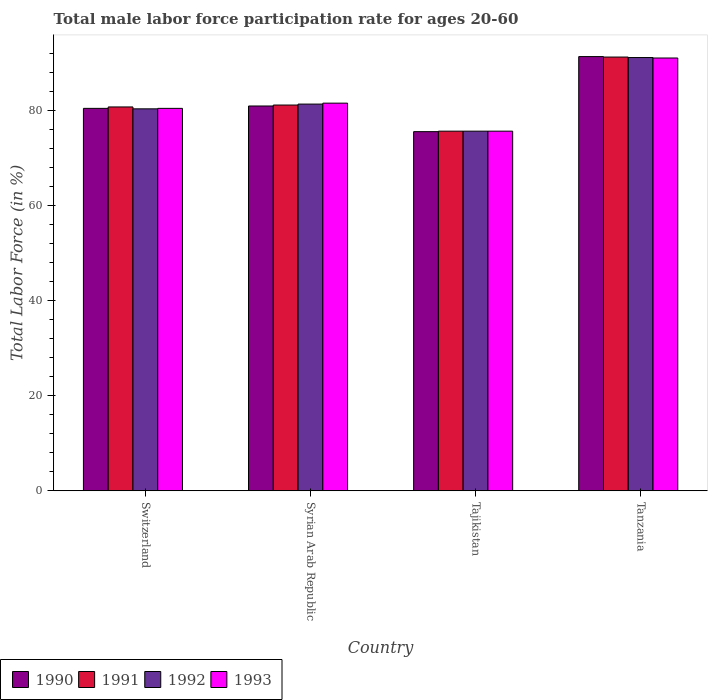Are the number of bars per tick equal to the number of legend labels?
Make the answer very short. Yes. Are the number of bars on each tick of the X-axis equal?
Provide a short and direct response. Yes. What is the label of the 1st group of bars from the left?
Your response must be concise. Switzerland. What is the male labor force participation rate in 1992 in Switzerland?
Provide a short and direct response. 80.4. Across all countries, what is the maximum male labor force participation rate in 1991?
Provide a short and direct response. 91.3. Across all countries, what is the minimum male labor force participation rate in 1993?
Ensure brevity in your answer.  75.7. In which country was the male labor force participation rate in 1993 maximum?
Your answer should be compact. Tanzania. In which country was the male labor force participation rate in 1992 minimum?
Give a very brief answer. Tajikistan. What is the total male labor force participation rate in 1992 in the graph?
Provide a short and direct response. 328.7. What is the difference between the male labor force participation rate in 1993 in Switzerland and that in Syrian Arab Republic?
Your answer should be compact. -1.1. What is the difference between the male labor force participation rate in 1990 in Tanzania and the male labor force participation rate in 1993 in Syrian Arab Republic?
Provide a short and direct response. 9.8. What is the average male labor force participation rate in 1993 per country?
Give a very brief answer. 82.22. What is the difference between the male labor force participation rate of/in 1993 and male labor force participation rate of/in 1991 in Syrian Arab Republic?
Give a very brief answer. 0.4. What is the ratio of the male labor force participation rate in 1991 in Switzerland to that in Tajikistan?
Provide a succinct answer. 1.07. Is the male labor force participation rate in 1990 in Syrian Arab Republic less than that in Tajikistan?
Offer a very short reply. No. Is the difference between the male labor force participation rate in 1993 in Syrian Arab Republic and Tanzania greater than the difference between the male labor force participation rate in 1991 in Syrian Arab Republic and Tanzania?
Make the answer very short. Yes. What is the difference between the highest and the lowest male labor force participation rate in 1990?
Offer a terse response. 15.8. Is the sum of the male labor force participation rate in 1990 in Switzerland and Tanzania greater than the maximum male labor force participation rate in 1992 across all countries?
Your answer should be very brief. Yes. Is it the case that in every country, the sum of the male labor force participation rate in 1990 and male labor force participation rate in 1993 is greater than the sum of male labor force participation rate in 1991 and male labor force participation rate in 1992?
Provide a succinct answer. No. What does the 2nd bar from the right in Syrian Arab Republic represents?
Make the answer very short. 1992. Are all the bars in the graph horizontal?
Provide a short and direct response. No. Does the graph contain any zero values?
Offer a very short reply. No. Where does the legend appear in the graph?
Give a very brief answer. Bottom left. How are the legend labels stacked?
Provide a short and direct response. Horizontal. What is the title of the graph?
Offer a terse response. Total male labor force participation rate for ages 20-60. What is the label or title of the Y-axis?
Keep it short and to the point. Total Labor Force (in %). What is the Total Labor Force (in %) in 1990 in Switzerland?
Make the answer very short. 80.5. What is the Total Labor Force (in %) of 1991 in Switzerland?
Offer a terse response. 80.8. What is the Total Labor Force (in %) of 1992 in Switzerland?
Provide a short and direct response. 80.4. What is the Total Labor Force (in %) in 1993 in Switzerland?
Your answer should be very brief. 80.5. What is the Total Labor Force (in %) of 1990 in Syrian Arab Republic?
Ensure brevity in your answer.  81. What is the Total Labor Force (in %) of 1991 in Syrian Arab Republic?
Provide a succinct answer. 81.2. What is the Total Labor Force (in %) in 1992 in Syrian Arab Republic?
Provide a succinct answer. 81.4. What is the Total Labor Force (in %) of 1993 in Syrian Arab Republic?
Give a very brief answer. 81.6. What is the Total Labor Force (in %) of 1990 in Tajikistan?
Provide a succinct answer. 75.6. What is the Total Labor Force (in %) of 1991 in Tajikistan?
Your answer should be compact. 75.7. What is the Total Labor Force (in %) of 1992 in Tajikistan?
Ensure brevity in your answer.  75.7. What is the Total Labor Force (in %) of 1993 in Tajikistan?
Ensure brevity in your answer.  75.7. What is the Total Labor Force (in %) in 1990 in Tanzania?
Give a very brief answer. 91.4. What is the Total Labor Force (in %) of 1991 in Tanzania?
Offer a terse response. 91.3. What is the Total Labor Force (in %) in 1992 in Tanzania?
Your answer should be very brief. 91.2. What is the Total Labor Force (in %) in 1993 in Tanzania?
Your answer should be very brief. 91.1. Across all countries, what is the maximum Total Labor Force (in %) in 1990?
Your response must be concise. 91.4. Across all countries, what is the maximum Total Labor Force (in %) of 1991?
Offer a terse response. 91.3. Across all countries, what is the maximum Total Labor Force (in %) in 1992?
Your response must be concise. 91.2. Across all countries, what is the maximum Total Labor Force (in %) in 1993?
Offer a very short reply. 91.1. Across all countries, what is the minimum Total Labor Force (in %) of 1990?
Your answer should be very brief. 75.6. Across all countries, what is the minimum Total Labor Force (in %) in 1991?
Provide a short and direct response. 75.7. Across all countries, what is the minimum Total Labor Force (in %) of 1992?
Your answer should be very brief. 75.7. Across all countries, what is the minimum Total Labor Force (in %) in 1993?
Your answer should be very brief. 75.7. What is the total Total Labor Force (in %) of 1990 in the graph?
Offer a very short reply. 328.5. What is the total Total Labor Force (in %) in 1991 in the graph?
Your answer should be compact. 329. What is the total Total Labor Force (in %) of 1992 in the graph?
Your answer should be compact. 328.7. What is the total Total Labor Force (in %) in 1993 in the graph?
Provide a succinct answer. 328.9. What is the difference between the Total Labor Force (in %) in 1990 in Switzerland and that in Syrian Arab Republic?
Make the answer very short. -0.5. What is the difference between the Total Labor Force (in %) of 1990 in Switzerland and that in Tajikistan?
Provide a short and direct response. 4.9. What is the difference between the Total Labor Force (in %) of 1991 in Switzerland and that in Tajikistan?
Your answer should be very brief. 5.1. What is the difference between the Total Labor Force (in %) of 1992 in Switzerland and that in Tajikistan?
Your answer should be very brief. 4.7. What is the difference between the Total Labor Force (in %) of 1993 in Switzerland and that in Tajikistan?
Offer a very short reply. 4.8. What is the difference between the Total Labor Force (in %) in 1990 in Switzerland and that in Tanzania?
Offer a terse response. -10.9. What is the difference between the Total Labor Force (in %) of 1992 in Switzerland and that in Tanzania?
Give a very brief answer. -10.8. What is the difference between the Total Labor Force (in %) of 1990 in Syrian Arab Republic and that in Tajikistan?
Keep it short and to the point. 5.4. What is the difference between the Total Labor Force (in %) in 1993 in Syrian Arab Republic and that in Tajikistan?
Provide a short and direct response. 5.9. What is the difference between the Total Labor Force (in %) of 1992 in Syrian Arab Republic and that in Tanzania?
Make the answer very short. -9.8. What is the difference between the Total Labor Force (in %) in 1993 in Syrian Arab Republic and that in Tanzania?
Your answer should be very brief. -9.5. What is the difference between the Total Labor Force (in %) of 1990 in Tajikistan and that in Tanzania?
Provide a succinct answer. -15.8. What is the difference between the Total Labor Force (in %) in 1991 in Tajikistan and that in Tanzania?
Provide a short and direct response. -15.6. What is the difference between the Total Labor Force (in %) of 1992 in Tajikistan and that in Tanzania?
Give a very brief answer. -15.5. What is the difference between the Total Labor Force (in %) of 1993 in Tajikistan and that in Tanzania?
Make the answer very short. -15.4. What is the difference between the Total Labor Force (in %) in 1990 in Switzerland and the Total Labor Force (in %) in 1991 in Syrian Arab Republic?
Your answer should be compact. -0.7. What is the difference between the Total Labor Force (in %) in 1990 in Switzerland and the Total Labor Force (in %) in 1992 in Syrian Arab Republic?
Provide a short and direct response. -0.9. What is the difference between the Total Labor Force (in %) in 1990 in Switzerland and the Total Labor Force (in %) in 1993 in Syrian Arab Republic?
Ensure brevity in your answer.  -1.1. What is the difference between the Total Labor Force (in %) in 1991 in Switzerland and the Total Labor Force (in %) in 1992 in Syrian Arab Republic?
Make the answer very short. -0.6. What is the difference between the Total Labor Force (in %) in 1992 in Switzerland and the Total Labor Force (in %) in 1993 in Syrian Arab Republic?
Your answer should be compact. -1.2. What is the difference between the Total Labor Force (in %) in 1990 in Switzerland and the Total Labor Force (in %) in 1991 in Tajikistan?
Ensure brevity in your answer.  4.8. What is the difference between the Total Labor Force (in %) in 1991 in Switzerland and the Total Labor Force (in %) in 1992 in Tajikistan?
Provide a succinct answer. 5.1. What is the difference between the Total Labor Force (in %) of 1992 in Switzerland and the Total Labor Force (in %) of 1993 in Tajikistan?
Your response must be concise. 4.7. What is the difference between the Total Labor Force (in %) of 1990 in Switzerland and the Total Labor Force (in %) of 1991 in Tanzania?
Your response must be concise. -10.8. What is the difference between the Total Labor Force (in %) of 1990 in Switzerland and the Total Labor Force (in %) of 1992 in Tanzania?
Offer a very short reply. -10.7. What is the difference between the Total Labor Force (in %) of 1991 in Switzerland and the Total Labor Force (in %) of 1992 in Tanzania?
Offer a terse response. -10.4. What is the difference between the Total Labor Force (in %) in 1990 in Syrian Arab Republic and the Total Labor Force (in %) in 1991 in Tajikistan?
Your response must be concise. 5.3. What is the difference between the Total Labor Force (in %) of 1990 in Syrian Arab Republic and the Total Labor Force (in %) of 1993 in Tajikistan?
Your response must be concise. 5.3. What is the difference between the Total Labor Force (in %) of 1991 in Syrian Arab Republic and the Total Labor Force (in %) of 1993 in Tajikistan?
Your answer should be very brief. 5.5. What is the difference between the Total Labor Force (in %) of 1992 in Syrian Arab Republic and the Total Labor Force (in %) of 1993 in Tajikistan?
Make the answer very short. 5.7. What is the difference between the Total Labor Force (in %) in 1990 in Syrian Arab Republic and the Total Labor Force (in %) in 1992 in Tanzania?
Your answer should be very brief. -10.2. What is the difference between the Total Labor Force (in %) of 1990 in Syrian Arab Republic and the Total Labor Force (in %) of 1993 in Tanzania?
Offer a very short reply. -10.1. What is the difference between the Total Labor Force (in %) in 1991 in Syrian Arab Republic and the Total Labor Force (in %) in 1993 in Tanzania?
Give a very brief answer. -9.9. What is the difference between the Total Labor Force (in %) of 1992 in Syrian Arab Republic and the Total Labor Force (in %) of 1993 in Tanzania?
Offer a very short reply. -9.7. What is the difference between the Total Labor Force (in %) in 1990 in Tajikistan and the Total Labor Force (in %) in 1991 in Tanzania?
Your response must be concise. -15.7. What is the difference between the Total Labor Force (in %) of 1990 in Tajikistan and the Total Labor Force (in %) of 1992 in Tanzania?
Make the answer very short. -15.6. What is the difference between the Total Labor Force (in %) in 1990 in Tajikistan and the Total Labor Force (in %) in 1993 in Tanzania?
Offer a terse response. -15.5. What is the difference between the Total Labor Force (in %) of 1991 in Tajikistan and the Total Labor Force (in %) of 1992 in Tanzania?
Provide a short and direct response. -15.5. What is the difference between the Total Labor Force (in %) in 1991 in Tajikistan and the Total Labor Force (in %) in 1993 in Tanzania?
Your response must be concise. -15.4. What is the difference between the Total Labor Force (in %) in 1992 in Tajikistan and the Total Labor Force (in %) in 1993 in Tanzania?
Offer a very short reply. -15.4. What is the average Total Labor Force (in %) of 1990 per country?
Offer a terse response. 82.12. What is the average Total Labor Force (in %) of 1991 per country?
Your answer should be compact. 82.25. What is the average Total Labor Force (in %) of 1992 per country?
Provide a succinct answer. 82.17. What is the average Total Labor Force (in %) of 1993 per country?
Give a very brief answer. 82.22. What is the difference between the Total Labor Force (in %) in 1990 and Total Labor Force (in %) in 1992 in Switzerland?
Keep it short and to the point. 0.1. What is the difference between the Total Labor Force (in %) of 1990 and Total Labor Force (in %) of 1993 in Switzerland?
Your answer should be very brief. 0. What is the difference between the Total Labor Force (in %) of 1991 and Total Labor Force (in %) of 1993 in Switzerland?
Ensure brevity in your answer.  0.3. What is the difference between the Total Labor Force (in %) in 1992 and Total Labor Force (in %) in 1993 in Switzerland?
Your answer should be compact. -0.1. What is the difference between the Total Labor Force (in %) of 1990 and Total Labor Force (in %) of 1993 in Syrian Arab Republic?
Your answer should be compact. -0.6. What is the difference between the Total Labor Force (in %) in 1991 and Total Labor Force (in %) in 1993 in Syrian Arab Republic?
Your response must be concise. -0.4. What is the difference between the Total Labor Force (in %) of 1990 and Total Labor Force (in %) of 1992 in Tajikistan?
Offer a very short reply. -0.1. What is the difference between the Total Labor Force (in %) in 1990 and Total Labor Force (in %) in 1992 in Tanzania?
Give a very brief answer. 0.2. What is the difference between the Total Labor Force (in %) of 1990 and Total Labor Force (in %) of 1993 in Tanzania?
Your answer should be very brief. 0.3. What is the ratio of the Total Labor Force (in %) in 1991 in Switzerland to that in Syrian Arab Republic?
Give a very brief answer. 1. What is the ratio of the Total Labor Force (in %) of 1993 in Switzerland to that in Syrian Arab Republic?
Your response must be concise. 0.99. What is the ratio of the Total Labor Force (in %) of 1990 in Switzerland to that in Tajikistan?
Ensure brevity in your answer.  1.06. What is the ratio of the Total Labor Force (in %) of 1991 in Switzerland to that in Tajikistan?
Make the answer very short. 1.07. What is the ratio of the Total Labor Force (in %) in 1992 in Switzerland to that in Tajikistan?
Your answer should be very brief. 1.06. What is the ratio of the Total Labor Force (in %) in 1993 in Switzerland to that in Tajikistan?
Make the answer very short. 1.06. What is the ratio of the Total Labor Force (in %) of 1990 in Switzerland to that in Tanzania?
Make the answer very short. 0.88. What is the ratio of the Total Labor Force (in %) in 1991 in Switzerland to that in Tanzania?
Provide a succinct answer. 0.89. What is the ratio of the Total Labor Force (in %) of 1992 in Switzerland to that in Tanzania?
Provide a succinct answer. 0.88. What is the ratio of the Total Labor Force (in %) of 1993 in Switzerland to that in Tanzania?
Ensure brevity in your answer.  0.88. What is the ratio of the Total Labor Force (in %) of 1990 in Syrian Arab Republic to that in Tajikistan?
Your answer should be very brief. 1.07. What is the ratio of the Total Labor Force (in %) of 1991 in Syrian Arab Republic to that in Tajikistan?
Keep it short and to the point. 1.07. What is the ratio of the Total Labor Force (in %) in 1992 in Syrian Arab Republic to that in Tajikistan?
Provide a succinct answer. 1.08. What is the ratio of the Total Labor Force (in %) in 1993 in Syrian Arab Republic to that in Tajikistan?
Provide a short and direct response. 1.08. What is the ratio of the Total Labor Force (in %) in 1990 in Syrian Arab Republic to that in Tanzania?
Your response must be concise. 0.89. What is the ratio of the Total Labor Force (in %) of 1991 in Syrian Arab Republic to that in Tanzania?
Your answer should be very brief. 0.89. What is the ratio of the Total Labor Force (in %) in 1992 in Syrian Arab Republic to that in Tanzania?
Ensure brevity in your answer.  0.89. What is the ratio of the Total Labor Force (in %) of 1993 in Syrian Arab Republic to that in Tanzania?
Your answer should be very brief. 0.9. What is the ratio of the Total Labor Force (in %) of 1990 in Tajikistan to that in Tanzania?
Your answer should be very brief. 0.83. What is the ratio of the Total Labor Force (in %) of 1991 in Tajikistan to that in Tanzania?
Make the answer very short. 0.83. What is the ratio of the Total Labor Force (in %) in 1992 in Tajikistan to that in Tanzania?
Offer a terse response. 0.83. What is the ratio of the Total Labor Force (in %) of 1993 in Tajikistan to that in Tanzania?
Provide a succinct answer. 0.83. What is the difference between the highest and the lowest Total Labor Force (in %) of 1990?
Make the answer very short. 15.8. What is the difference between the highest and the lowest Total Labor Force (in %) of 1991?
Ensure brevity in your answer.  15.6. 